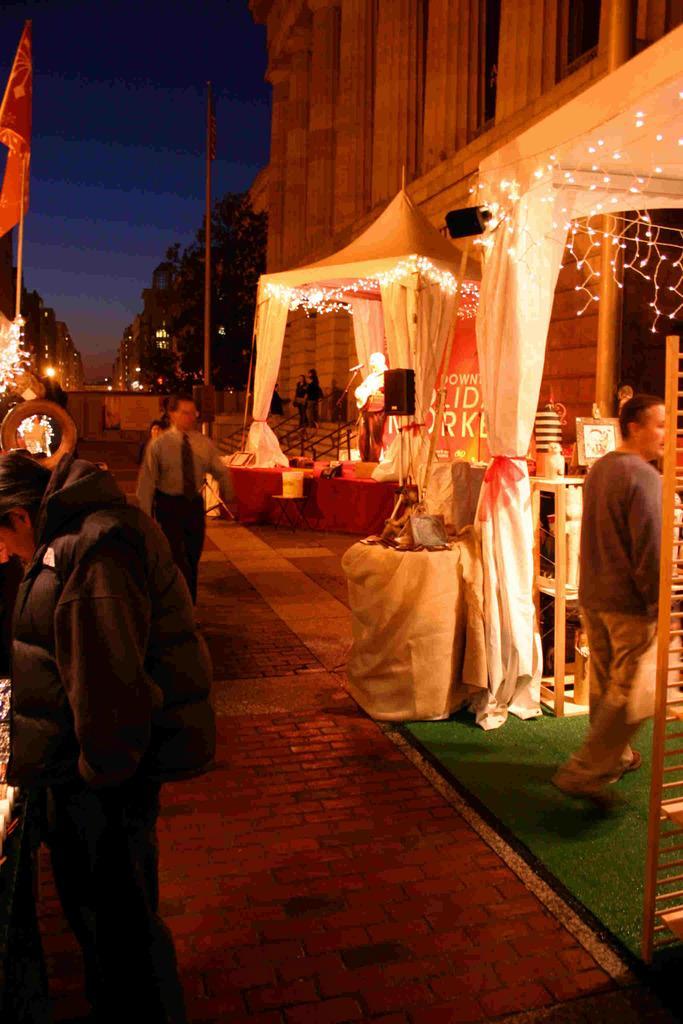Could you give a brief overview of what you see in this image? In this image I can see people standing on the ground. Here I can see white color curtains, lights, a flag, a pole and other objects on the ground. In the background I can see buildings and the sky. 